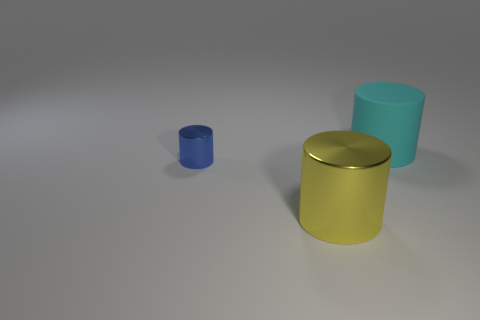There is another thing that is made of the same material as the yellow thing; what color is it?
Ensure brevity in your answer.  Blue. Are the large cylinder that is behind the blue metal thing and the cylinder left of the yellow cylinder made of the same material?
Offer a very short reply. No. Are there any other yellow objects of the same size as the yellow metal thing?
Ensure brevity in your answer.  No. What is the size of the cylinder that is to the right of the large object that is in front of the cyan object?
Ensure brevity in your answer.  Large. There is a big object to the left of the thing behind the blue shiny cylinder; what is its shape?
Ensure brevity in your answer.  Cylinder. How many yellow things are the same material as the blue thing?
Provide a short and direct response. 1. There is a large cylinder on the left side of the large cyan matte cylinder; what is it made of?
Offer a terse response. Metal. There is a object in front of the metal cylinder left of the big cylinder that is on the left side of the large cyan matte thing; what is its shape?
Keep it short and to the point. Cylinder. There is a big object that is left of the rubber thing; is it the same color as the big object behind the tiny blue cylinder?
Keep it short and to the point. No. Is the number of small metal objects that are left of the yellow object less than the number of large yellow objects on the left side of the small blue shiny thing?
Provide a succinct answer. No. 